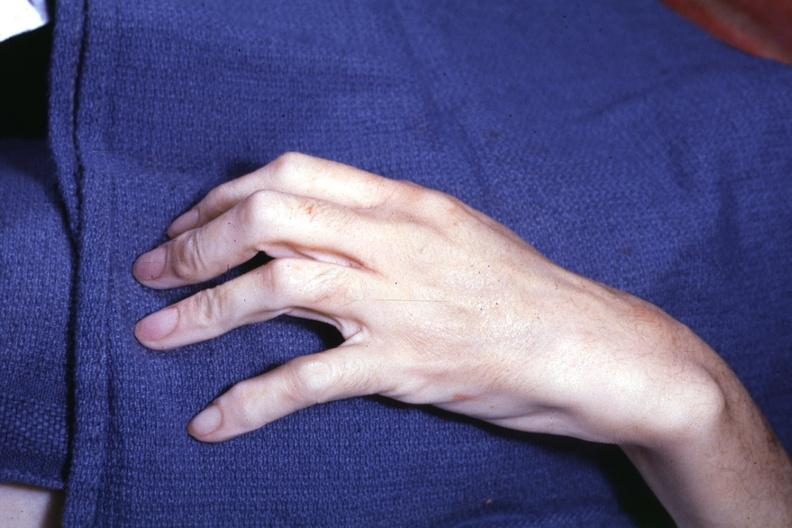what does this image show?
Answer the question using a single word or phrase. Long fingers interesting case see other slides 